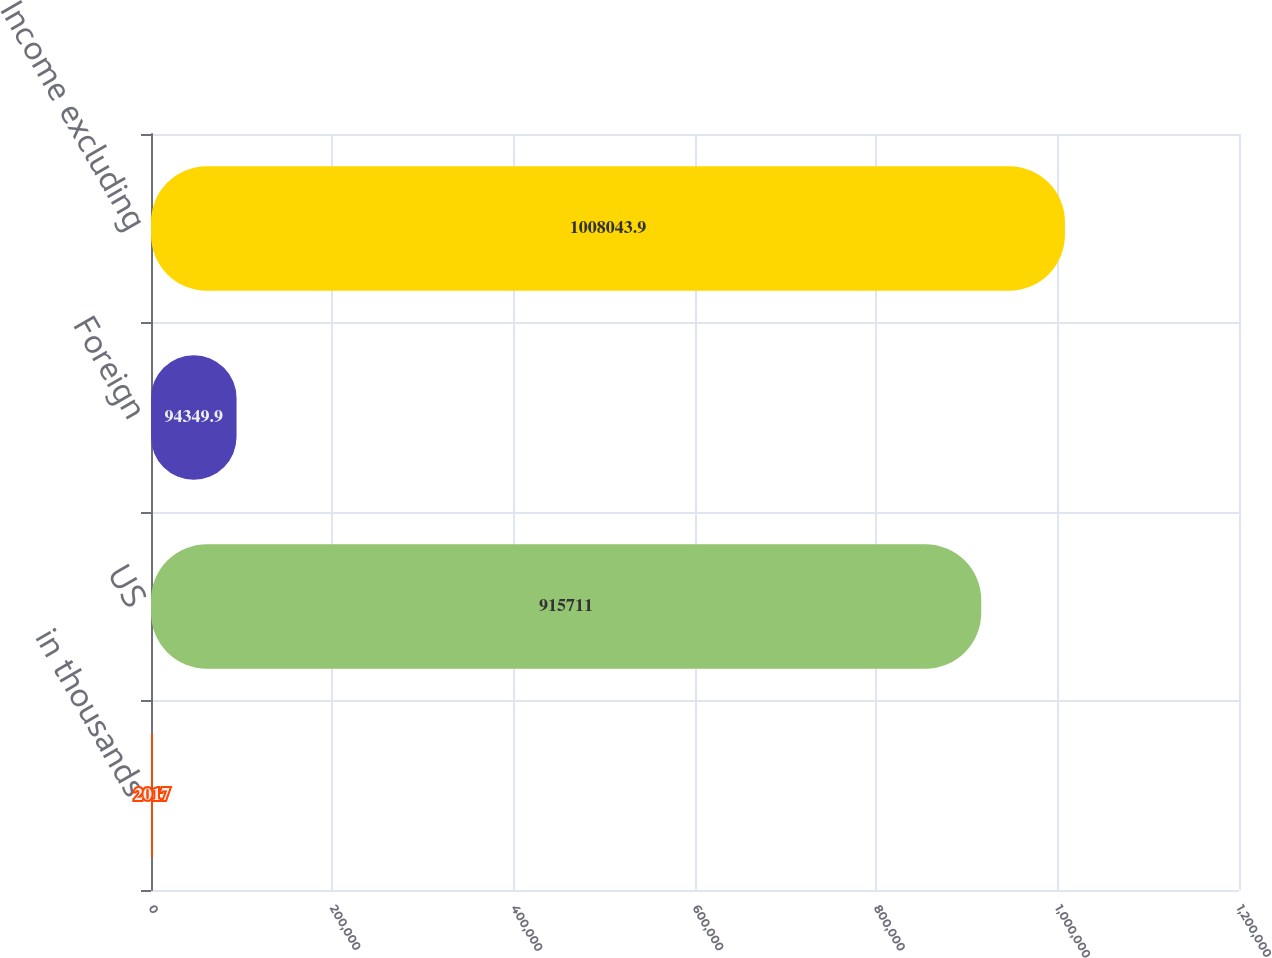<chart> <loc_0><loc_0><loc_500><loc_500><bar_chart><fcel>in thousands<fcel>US<fcel>Foreign<fcel>Income excluding<nl><fcel>2017<fcel>915711<fcel>94349.9<fcel>1.00804e+06<nl></chart> 